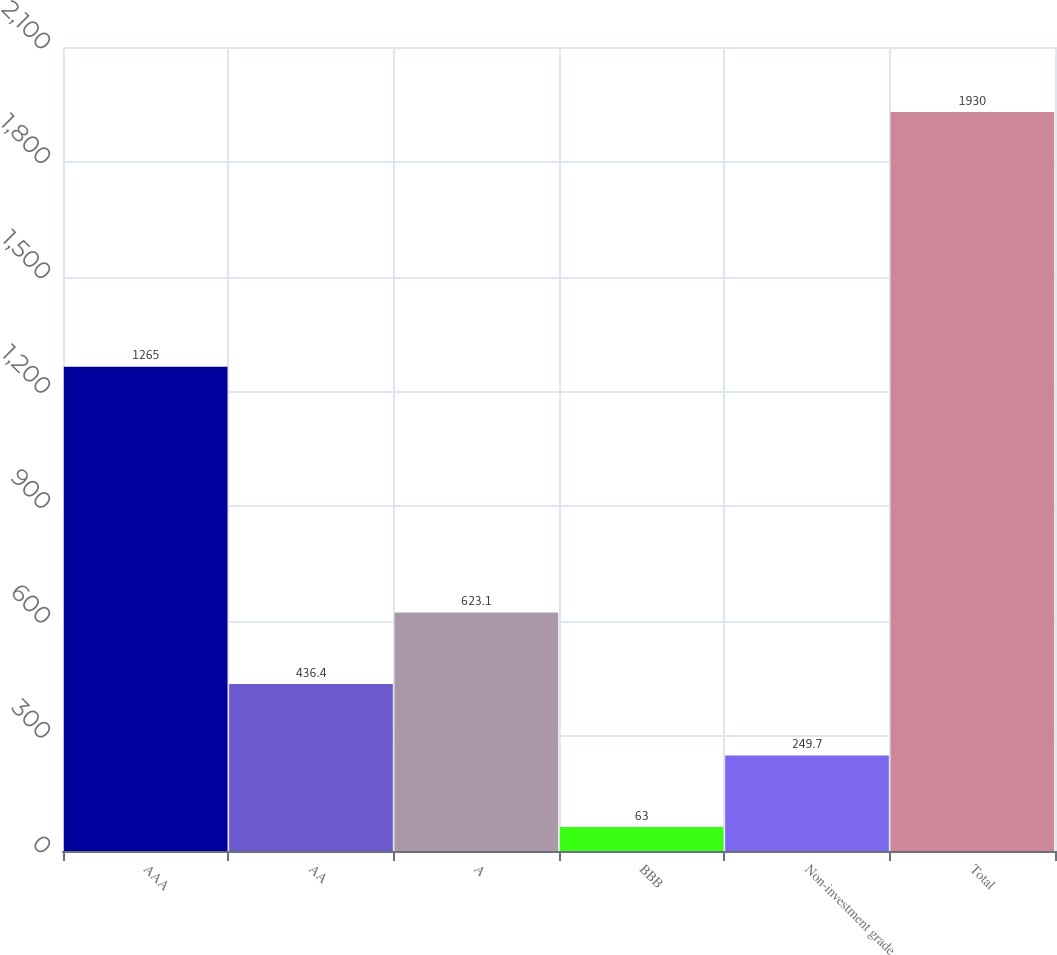Convert chart to OTSL. <chart><loc_0><loc_0><loc_500><loc_500><bar_chart><fcel>AAA<fcel>AA<fcel>A<fcel>BBB<fcel>Non-investment grade<fcel>Total<nl><fcel>1265<fcel>436.4<fcel>623.1<fcel>63<fcel>249.7<fcel>1930<nl></chart> 